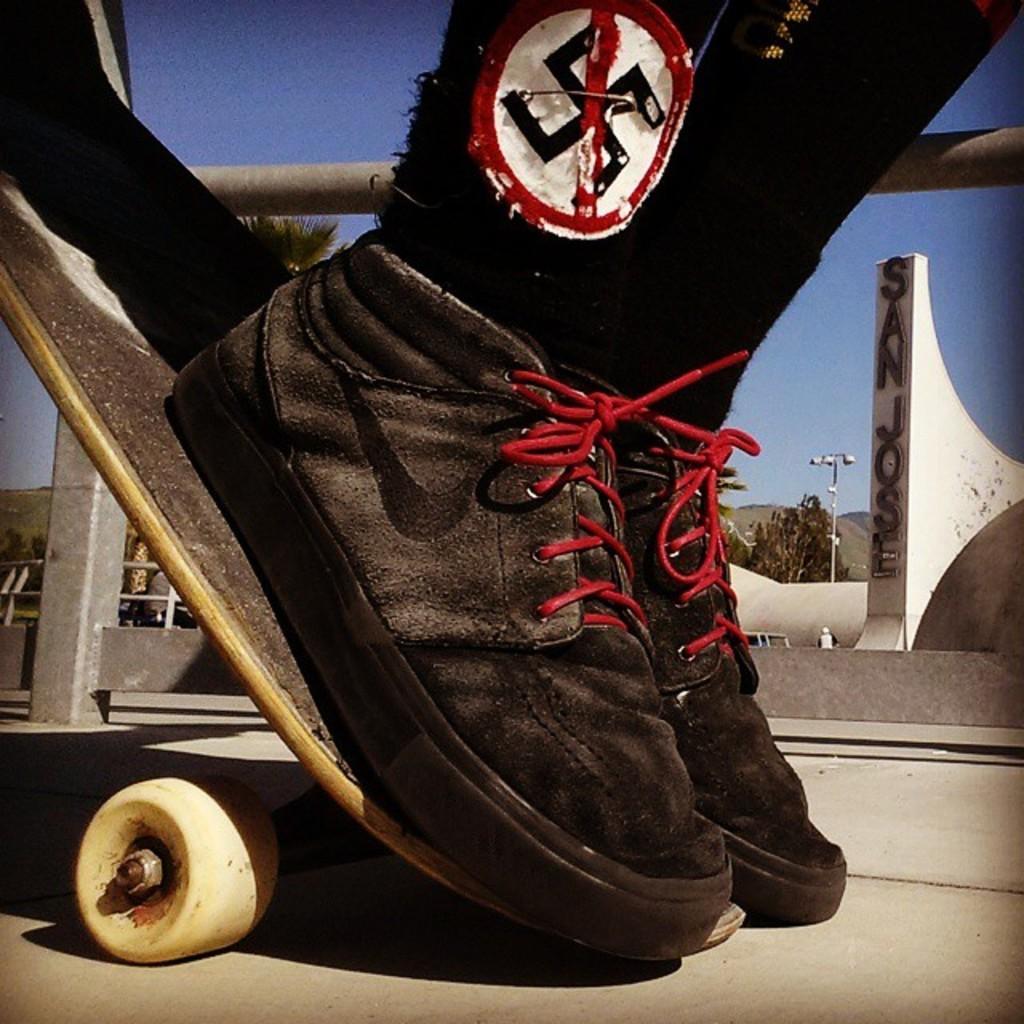Can you describe this image briefly? As we can see in the image there is a skateboard and black color shoes. In the background there is a street lamp and trees. On the top there is a sky. 